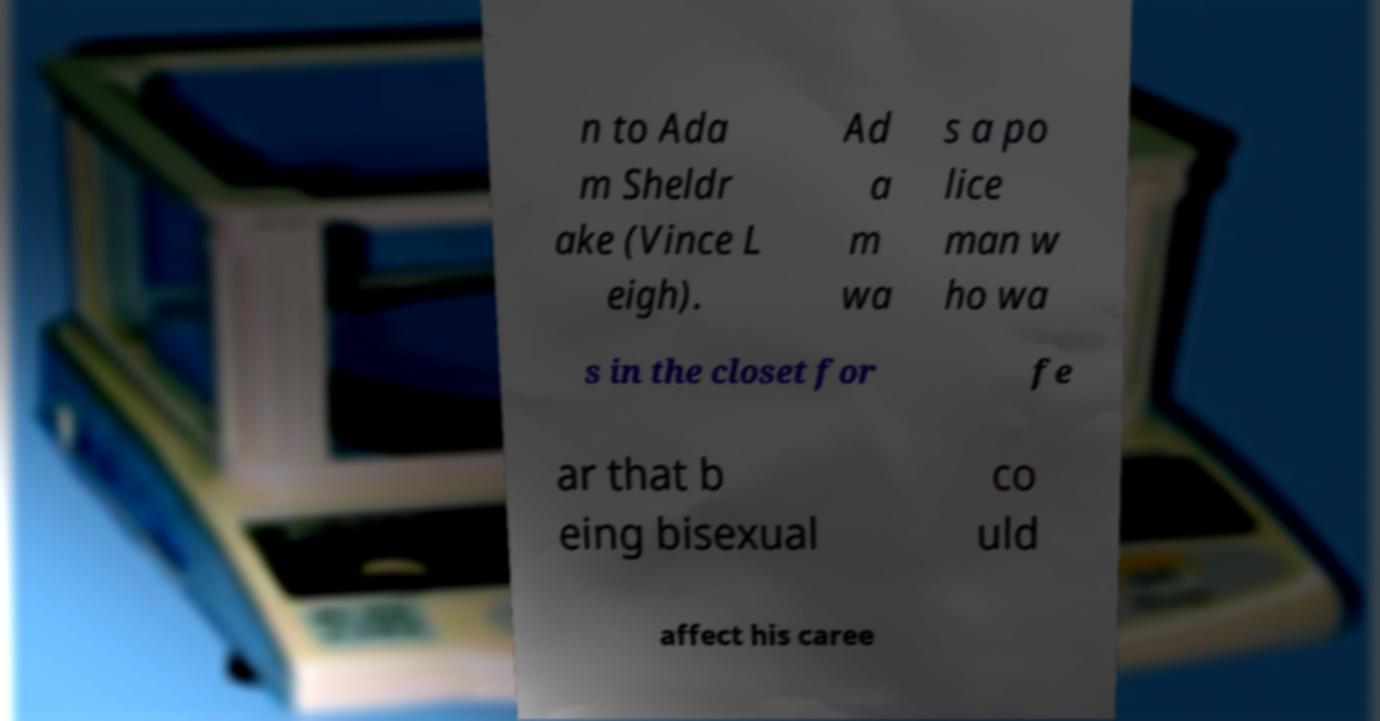What messages or text are displayed in this image? I need them in a readable, typed format. n to Ada m Sheldr ake (Vince L eigh). Ad a m wa s a po lice man w ho wa s in the closet for fe ar that b eing bisexual co uld affect his caree 